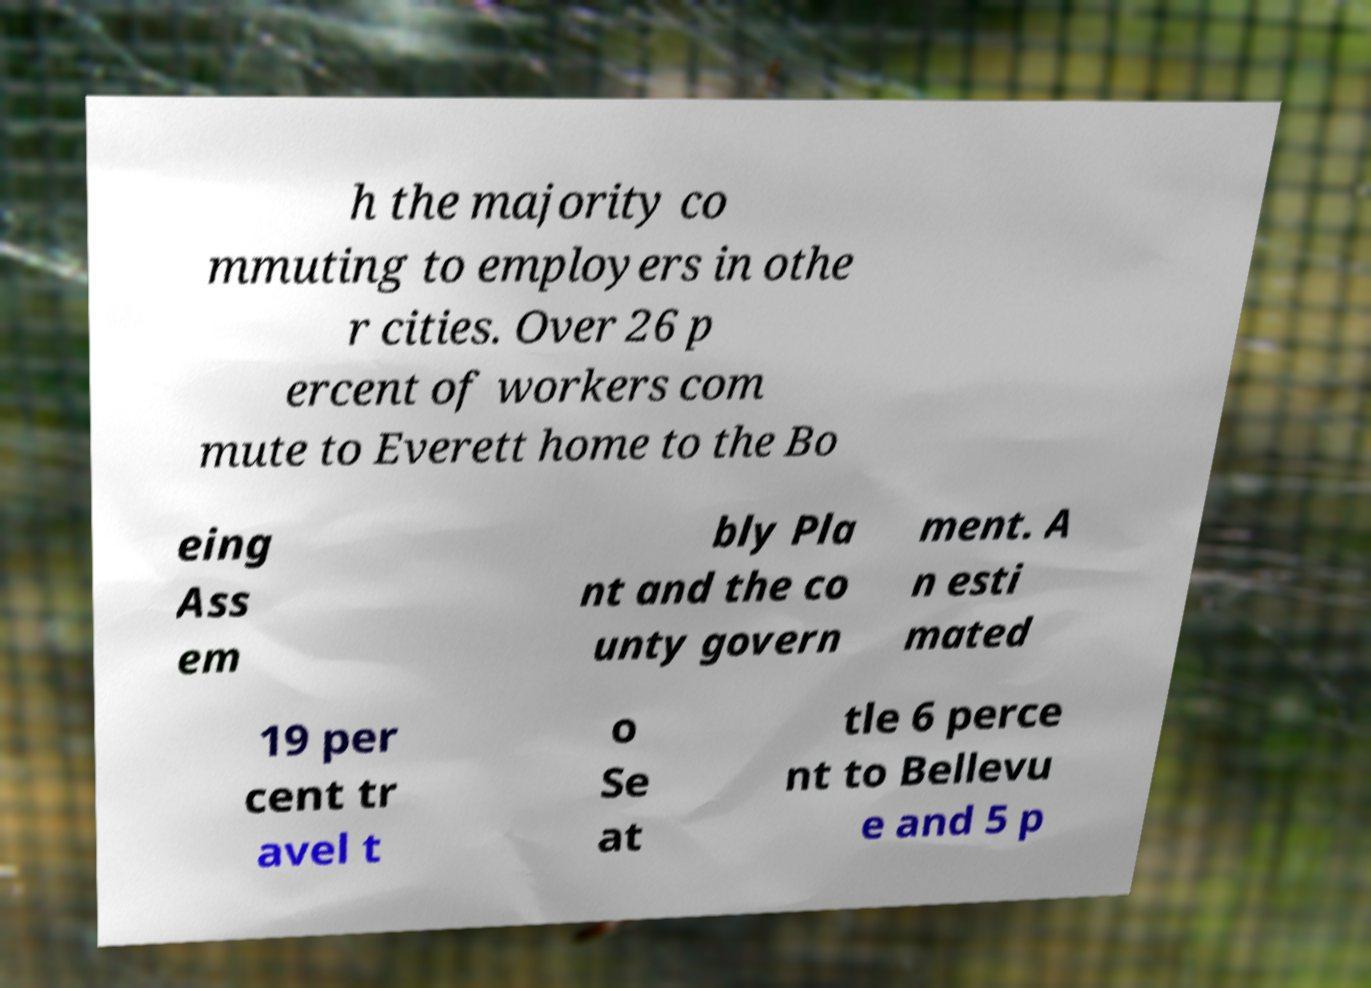What messages or text are displayed in this image? I need them in a readable, typed format. h the majority co mmuting to employers in othe r cities. Over 26 p ercent of workers com mute to Everett home to the Bo eing Ass em bly Pla nt and the co unty govern ment. A n esti mated 19 per cent tr avel t o Se at tle 6 perce nt to Bellevu e and 5 p 